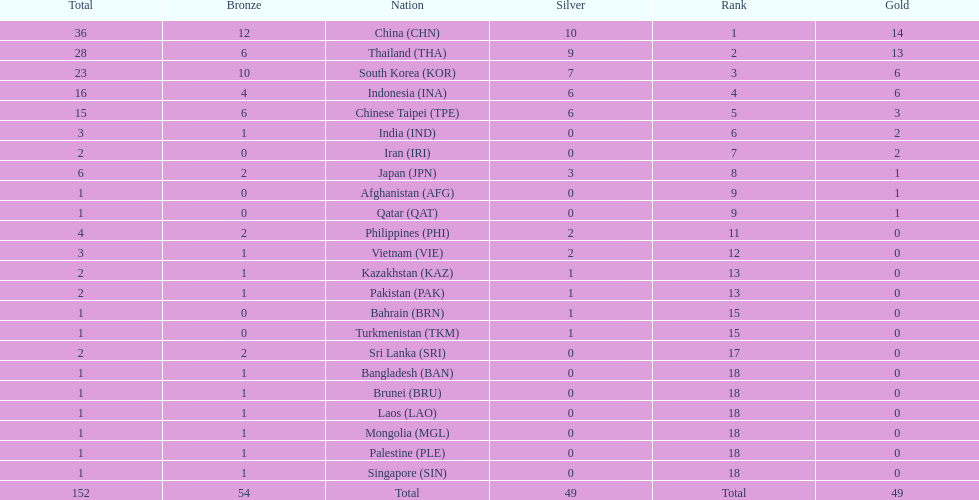Which countries won the same number of gold medals as japan? Afghanistan (AFG), Qatar (QAT). 